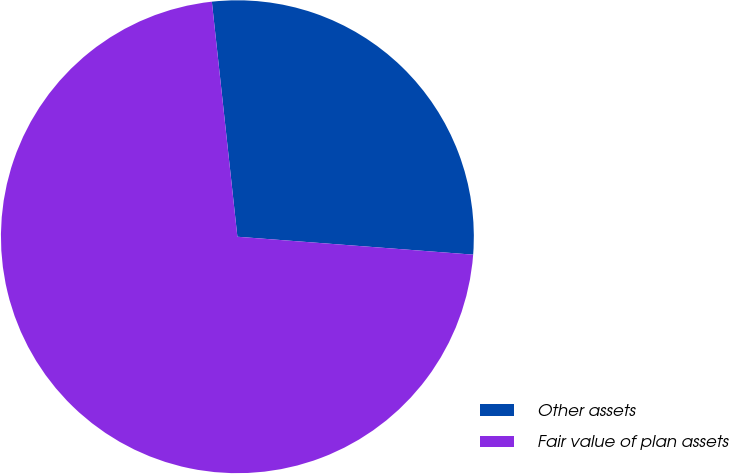Convert chart to OTSL. <chart><loc_0><loc_0><loc_500><loc_500><pie_chart><fcel>Other assets<fcel>Fair value of plan assets<nl><fcel>27.93%<fcel>72.07%<nl></chart> 